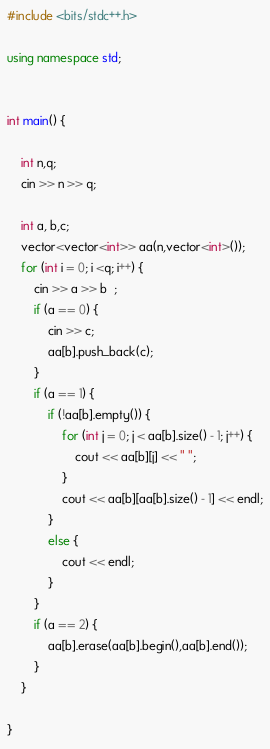Convert code to text. <code><loc_0><loc_0><loc_500><loc_500><_C++_>#include <bits/stdc++.h>

using namespace std;


int main() {

	int n,q;
	cin >> n >> q;

	int a, b,c;
	vector<vector<int>> aa(n,vector<int>());
	for (int i = 0; i <q; i++) {
		cin >> a >> b  ;
		if (a == 0) {
			cin >> c;
			aa[b].push_back(c);
		}
		if (a == 1) {
			if (!aa[b].empty()) {
				for (int j = 0; j < aa[b].size() - 1; j++) {
					cout << aa[b][j] << " ";
				}
				cout << aa[b][aa[b].size() - 1] << endl;
			}
			else {
				cout << endl;
			}
		}
		if (a == 2) {
			aa[b].erase(aa[b].begin(),aa[b].end());
		}
	}

}
</code> 